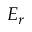Convert formula to latex. <formula><loc_0><loc_0><loc_500><loc_500>E _ { r }</formula> 